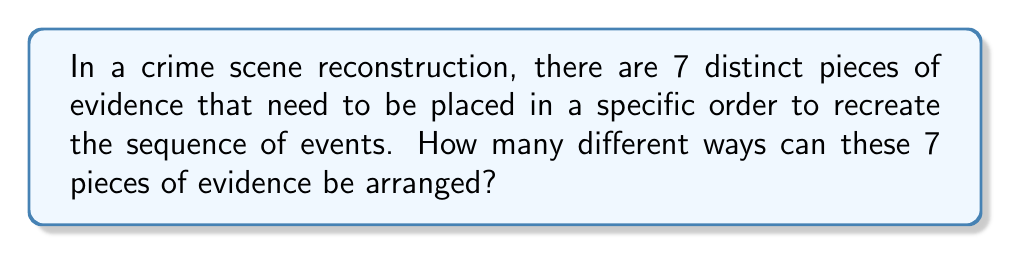Could you help me with this problem? To solve this problem, we need to consider the following steps:

1. Recognize that this is a permutation problem. We are arranging all 7 pieces of evidence in different orders, and the order matters.

2. Recall the formula for permutations:
   For n distinct objects, the number of permutations is given by:
   $$P(n) = n!$$

3. In this case, we have 7 distinct pieces of evidence, so n = 7.

4. Apply the formula:
   $$P(7) = 7!$$

5. Calculate 7!:
   $$7! = 7 \times 6 \times 5 \times 4 \times 3 \times 2 \times 1 = 5040$$

Therefore, there are 5040 different ways to arrange the 7 pieces of evidence in the crime scene reconstruction.
Answer: 5040 